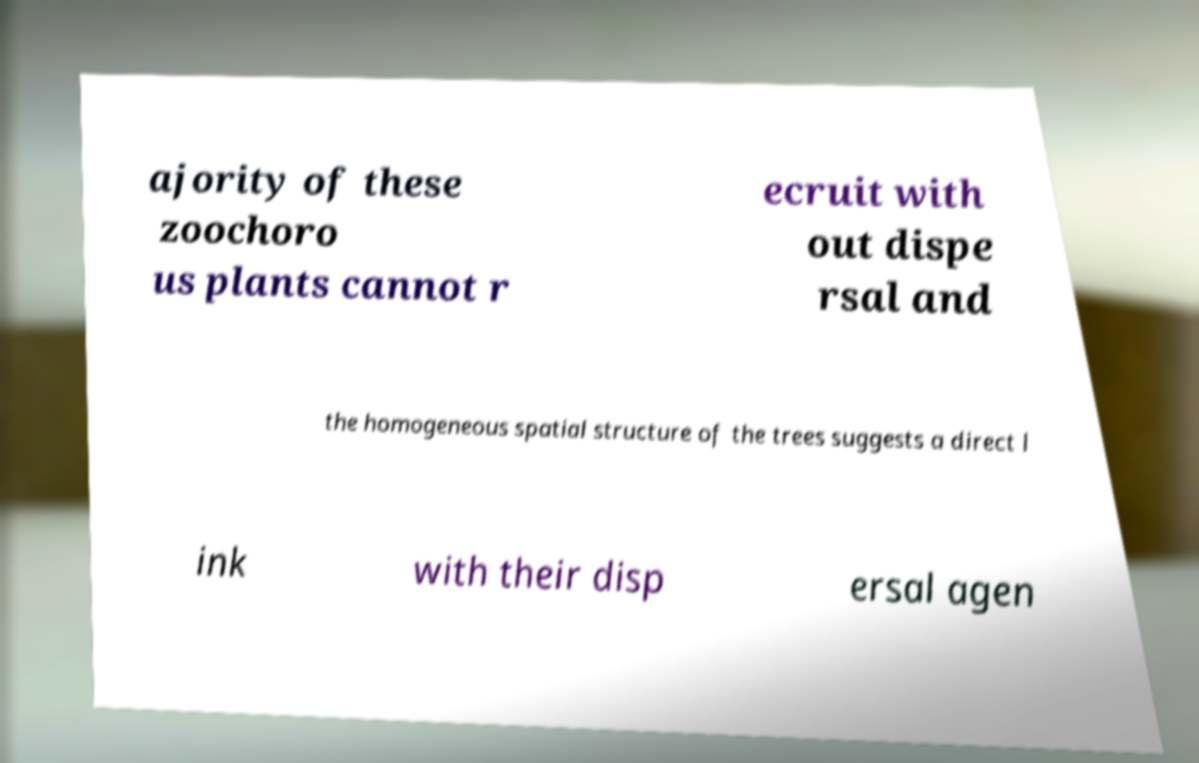I need the written content from this picture converted into text. Can you do that? ajority of these zoochoro us plants cannot r ecruit with out dispe rsal and the homogeneous spatial structure of the trees suggests a direct l ink with their disp ersal agen 